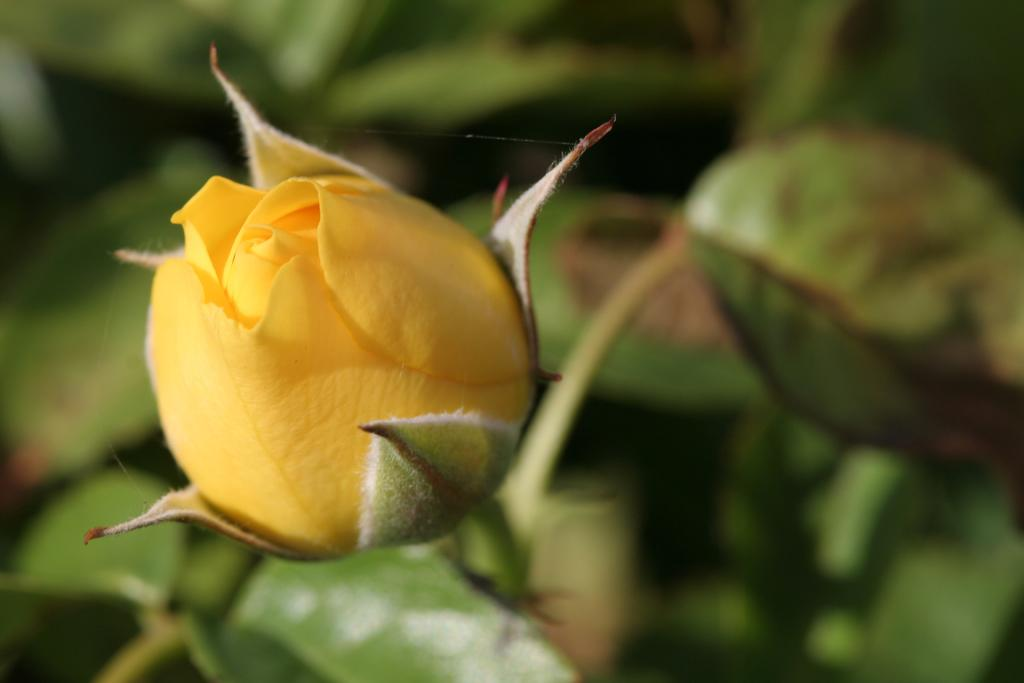What is the main subject of the image? A: There is an unbloomed yellow rose in the center of the image. What type of plants are visible at the bottom of the image? There are plants at the bottom of the image. How many planes can be seen flying through the rainstorm in the image? There are no planes or rainstorms present in the image; it features a yellow rose and plants. 